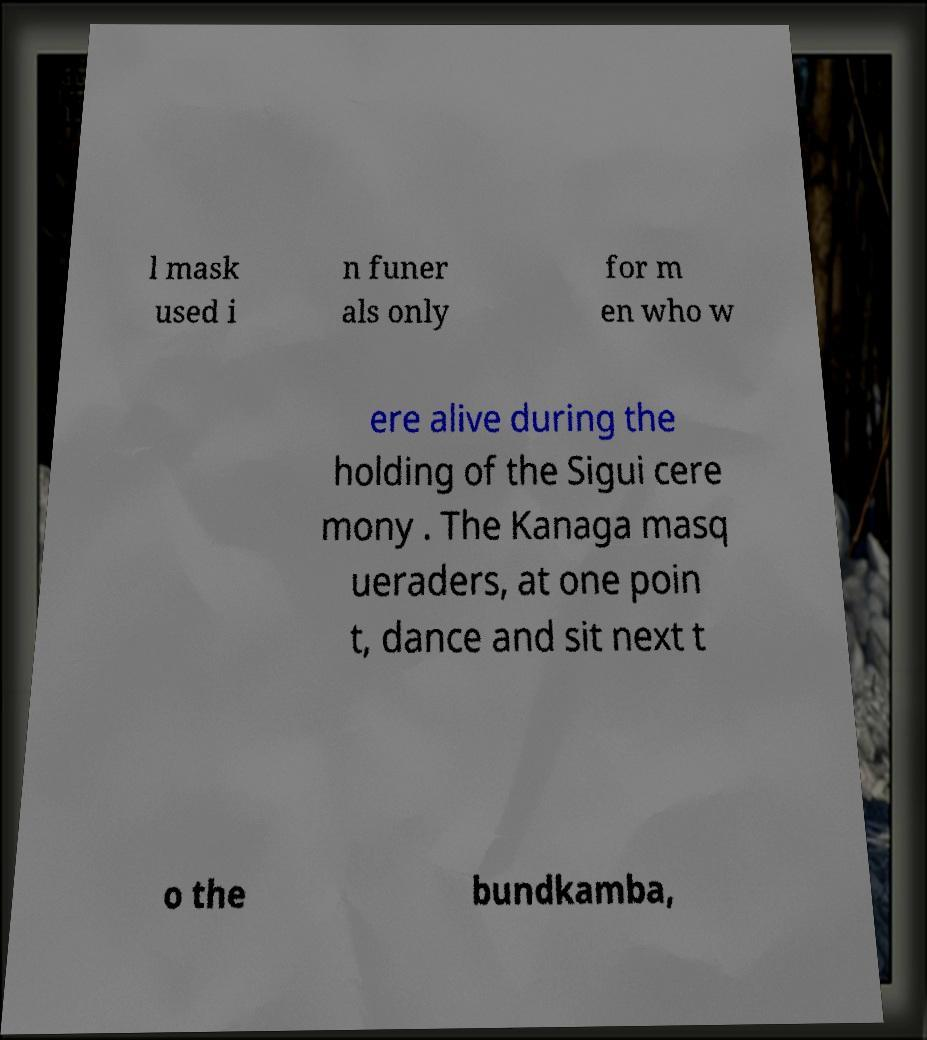Could you assist in decoding the text presented in this image and type it out clearly? l mask used i n funer als only for m en who w ere alive during the holding of the Sigui cere mony . The Kanaga masq ueraders, at one poin t, dance and sit next t o the bundkamba, 